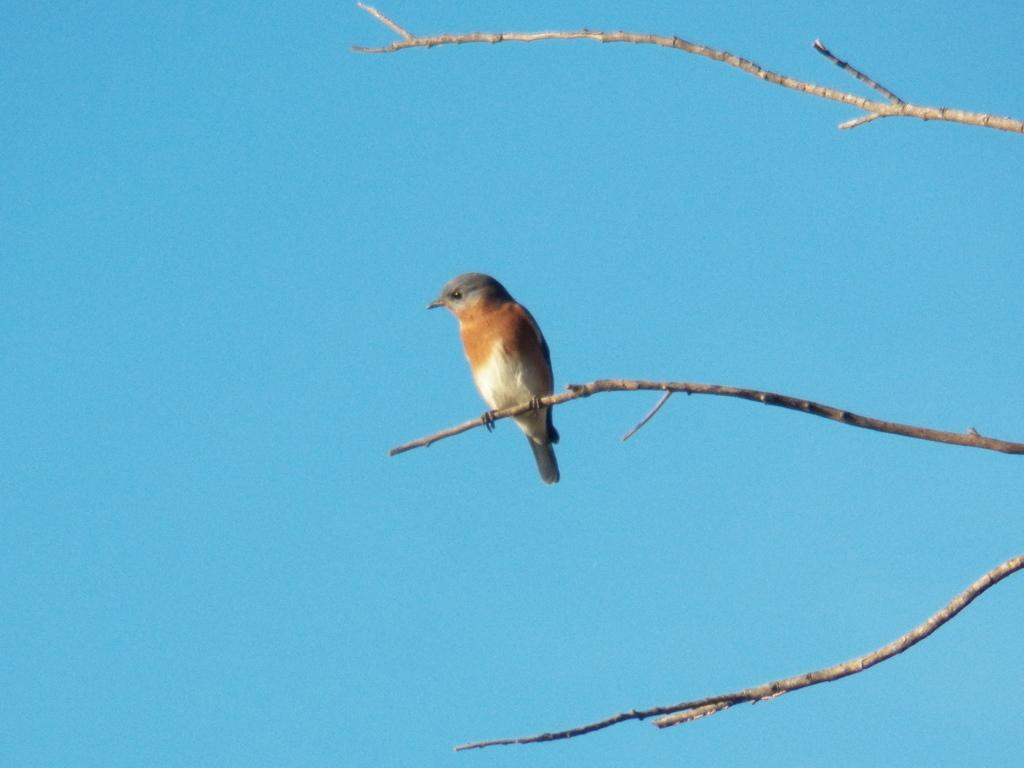What type of animal can be seen in the image? There is a bird in the image. Where is the bird located in the image? The bird is on a branch. What color is the sky in the image? The sky is blue in the image. What type of meal is the bird eating in the image? There is no meal present in the image; the bird is simply perched on a branch. 